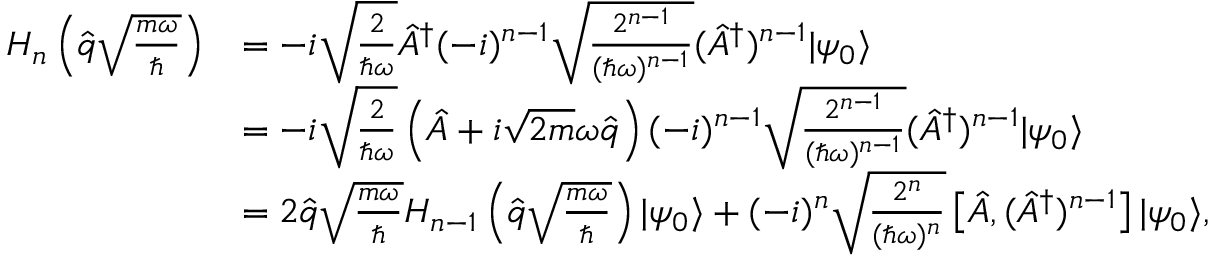Convert formula to latex. <formula><loc_0><loc_0><loc_500><loc_500>\begin{array} { r l } { H _ { n } \left ( \hat { q } \sqrt { \frac { m \omega } { } } \right ) } & { = - i \sqrt { \frac { 2 } { \hbar { \omega } } } \hat { A } ^ { \dagger } ( - i ) ^ { n - 1 } \sqrt { \frac { 2 ^ { n - 1 } } { ( \hbar { \omega } ) ^ { n - 1 } } } ( \hat { A } ^ { \dagger } ) ^ { n - 1 } | \psi _ { 0 } \rangle } \\ & { = - i \sqrt { \frac { 2 } { \hbar { \omega } } } \left ( \hat { A } + i \sqrt { 2 m } \omega \hat { q } \right ) ( - i ) ^ { n - 1 } \sqrt { \frac { 2 ^ { n - 1 } } { ( \hbar { \omega } ) ^ { n - 1 } } } ( \hat { A } ^ { \dagger } ) ^ { n - 1 } | \psi _ { 0 } \rangle } \\ & { = 2 \hat { q } \sqrt { \frac { m \omega } { } } H _ { n - 1 } \left ( \hat { q } \sqrt { \frac { m \omega } { } } \right ) | \psi _ { 0 } \rangle + ( - i ) ^ { n } \sqrt { \frac { 2 ^ { n } } { ( \hbar { \omega } ) ^ { n } } } \left [ \hat { A } , ( \hat { A } ^ { \dagger } ) ^ { n - 1 } \right ] | \psi _ { 0 } \rangle , } \end{array}</formula> 